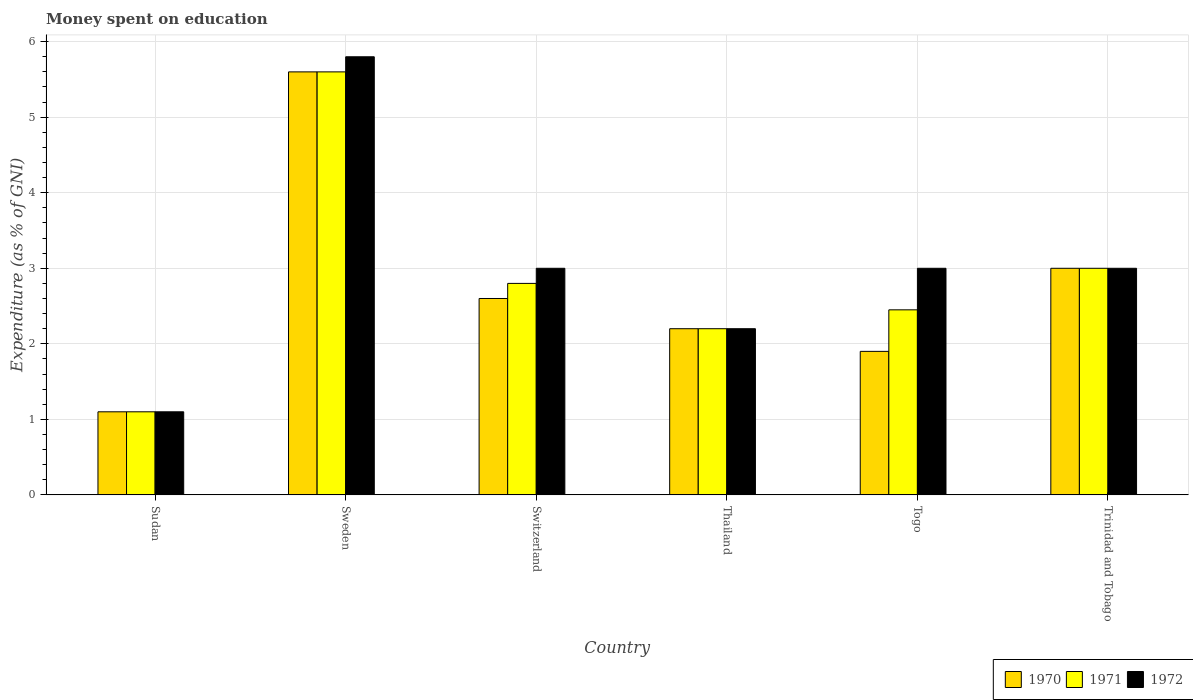How many groups of bars are there?
Your answer should be compact. 6. How many bars are there on the 1st tick from the right?
Provide a short and direct response. 3. What is the label of the 3rd group of bars from the left?
Ensure brevity in your answer.  Switzerland. In how many cases, is the number of bars for a given country not equal to the number of legend labels?
Give a very brief answer. 0. What is the amount of money spent on education in 1971 in Trinidad and Tobago?
Your answer should be compact. 3. Across all countries, what is the maximum amount of money spent on education in 1970?
Your answer should be very brief. 5.6. Across all countries, what is the minimum amount of money spent on education in 1972?
Your response must be concise. 1.1. In which country was the amount of money spent on education in 1970 minimum?
Offer a very short reply. Sudan. What is the total amount of money spent on education in 1970 in the graph?
Provide a succinct answer. 16.4. What is the difference between the amount of money spent on education in 1971 in Sudan and that in Thailand?
Offer a very short reply. -1.1. What is the difference between the amount of money spent on education in 1970 in Thailand and the amount of money spent on education in 1971 in Sweden?
Your answer should be very brief. -3.4. What is the average amount of money spent on education in 1972 per country?
Make the answer very short. 3.02. What is the difference between the amount of money spent on education of/in 1971 and amount of money spent on education of/in 1972 in Sweden?
Make the answer very short. -0.2. In how many countries, is the amount of money spent on education in 1970 greater than 5.6 %?
Your answer should be compact. 0. What is the ratio of the amount of money spent on education in 1970 in Thailand to that in Togo?
Give a very brief answer. 1.16. Is the amount of money spent on education in 1971 in Thailand less than that in Trinidad and Tobago?
Offer a very short reply. Yes. Is the difference between the amount of money spent on education in 1971 in Sweden and Trinidad and Tobago greater than the difference between the amount of money spent on education in 1972 in Sweden and Trinidad and Tobago?
Your answer should be compact. No. What is the difference between the highest and the second highest amount of money spent on education in 1970?
Give a very brief answer. -0.4. What is the difference between the highest and the lowest amount of money spent on education in 1972?
Give a very brief answer. 4.7. Is the sum of the amount of money spent on education in 1970 in Sudan and Switzerland greater than the maximum amount of money spent on education in 1971 across all countries?
Ensure brevity in your answer.  No. What does the 2nd bar from the left in Switzerland represents?
Offer a very short reply. 1971. What does the 1st bar from the right in Trinidad and Tobago represents?
Offer a very short reply. 1972. Are the values on the major ticks of Y-axis written in scientific E-notation?
Your answer should be very brief. No. Does the graph contain any zero values?
Make the answer very short. No. Does the graph contain grids?
Your answer should be very brief. Yes. How many legend labels are there?
Your answer should be compact. 3. How are the legend labels stacked?
Provide a short and direct response. Horizontal. What is the title of the graph?
Ensure brevity in your answer.  Money spent on education. What is the label or title of the X-axis?
Your response must be concise. Country. What is the label or title of the Y-axis?
Ensure brevity in your answer.  Expenditure (as % of GNI). What is the Expenditure (as % of GNI) of 1970 in Sudan?
Provide a short and direct response. 1.1. What is the Expenditure (as % of GNI) in 1971 in Sudan?
Ensure brevity in your answer.  1.1. What is the Expenditure (as % of GNI) in 1972 in Sweden?
Offer a terse response. 5.8. What is the Expenditure (as % of GNI) of 1972 in Switzerland?
Keep it short and to the point. 3. What is the Expenditure (as % of GNI) of 1970 in Togo?
Provide a succinct answer. 1.9. What is the Expenditure (as % of GNI) in 1971 in Togo?
Make the answer very short. 2.45. What is the Expenditure (as % of GNI) in 1972 in Togo?
Your response must be concise. 3. What is the Expenditure (as % of GNI) of 1970 in Trinidad and Tobago?
Your answer should be compact. 3. Across all countries, what is the maximum Expenditure (as % of GNI) of 1970?
Your answer should be very brief. 5.6. Across all countries, what is the maximum Expenditure (as % of GNI) of 1971?
Offer a terse response. 5.6. Across all countries, what is the maximum Expenditure (as % of GNI) in 1972?
Your answer should be very brief. 5.8. Across all countries, what is the minimum Expenditure (as % of GNI) in 1971?
Ensure brevity in your answer.  1.1. Across all countries, what is the minimum Expenditure (as % of GNI) of 1972?
Offer a terse response. 1.1. What is the total Expenditure (as % of GNI) in 1971 in the graph?
Make the answer very short. 17.15. What is the difference between the Expenditure (as % of GNI) of 1972 in Sudan and that in Sweden?
Provide a succinct answer. -4.7. What is the difference between the Expenditure (as % of GNI) in 1970 in Sudan and that in Switzerland?
Make the answer very short. -1.5. What is the difference between the Expenditure (as % of GNI) of 1971 in Sudan and that in Switzerland?
Your answer should be compact. -1.7. What is the difference between the Expenditure (as % of GNI) of 1972 in Sudan and that in Switzerland?
Your response must be concise. -1.9. What is the difference between the Expenditure (as % of GNI) in 1970 in Sudan and that in Togo?
Your answer should be compact. -0.8. What is the difference between the Expenditure (as % of GNI) of 1971 in Sudan and that in Togo?
Give a very brief answer. -1.35. What is the difference between the Expenditure (as % of GNI) in 1971 in Sudan and that in Trinidad and Tobago?
Provide a short and direct response. -1.9. What is the difference between the Expenditure (as % of GNI) of 1972 in Sudan and that in Trinidad and Tobago?
Your answer should be compact. -1.9. What is the difference between the Expenditure (as % of GNI) in 1971 in Sweden and that in Switzerland?
Make the answer very short. 2.8. What is the difference between the Expenditure (as % of GNI) of 1972 in Sweden and that in Switzerland?
Provide a short and direct response. 2.8. What is the difference between the Expenditure (as % of GNI) of 1971 in Sweden and that in Thailand?
Your response must be concise. 3.4. What is the difference between the Expenditure (as % of GNI) in 1970 in Sweden and that in Togo?
Offer a very short reply. 3.7. What is the difference between the Expenditure (as % of GNI) of 1971 in Sweden and that in Togo?
Offer a terse response. 3.15. What is the difference between the Expenditure (as % of GNI) in 1972 in Sweden and that in Togo?
Provide a short and direct response. 2.8. What is the difference between the Expenditure (as % of GNI) in 1972 in Switzerland and that in Thailand?
Keep it short and to the point. 0.8. What is the difference between the Expenditure (as % of GNI) in 1970 in Switzerland and that in Togo?
Your answer should be compact. 0.7. What is the difference between the Expenditure (as % of GNI) of 1971 in Switzerland and that in Togo?
Offer a very short reply. 0.35. What is the difference between the Expenditure (as % of GNI) of 1971 in Switzerland and that in Trinidad and Tobago?
Offer a terse response. -0.2. What is the difference between the Expenditure (as % of GNI) of 1970 in Thailand and that in Togo?
Your answer should be very brief. 0.3. What is the difference between the Expenditure (as % of GNI) in 1971 in Thailand and that in Togo?
Offer a very short reply. -0.25. What is the difference between the Expenditure (as % of GNI) of 1971 in Thailand and that in Trinidad and Tobago?
Your answer should be very brief. -0.8. What is the difference between the Expenditure (as % of GNI) in 1970 in Togo and that in Trinidad and Tobago?
Your response must be concise. -1.1. What is the difference between the Expenditure (as % of GNI) in 1971 in Togo and that in Trinidad and Tobago?
Your answer should be very brief. -0.55. What is the difference between the Expenditure (as % of GNI) of 1970 in Sudan and the Expenditure (as % of GNI) of 1971 in Sweden?
Your response must be concise. -4.5. What is the difference between the Expenditure (as % of GNI) of 1971 in Sudan and the Expenditure (as % of GNI) of 1972 in Sweden?
Your response must be concise. -4.7. What is the difference between the Expenditure (as % of GNI) of 1971 in Sudan and the Expenditure (as % of GNI) of 1972 in Switzerland?
Make the answer very short. -1.9. What is the difference between the Expenditure (as % of GNI) in 1971 in Sudan and the Expenditure (as % of GNI) in 1972 in Thailand?
Offer a very short reply. -1.1. What is the difference between the Expenditure (as % of GNI) in 1970 in Sudan and the Expenditure (as % of GNI) in 1971 in Togo?
Offer a terse response. -1.35. What is the difference between the Expenditure (as % of GNI) in 1970 in Sudan and the Expenditure (as % of GNI) in 1972 in Togo?
Provide a succinct answer. -1.9. What is the difference between the Expenditure (as % of GNI) in 1971 in Sudan and the Expenditure (as % of GNI) in 1972 in Togo?
Your answer should be compact. -1.9. What is the difference between the Expenditure (as % of GNI) in 1970 in Sweden and the Expenditure (as % of GNI) in 1971 in Thailand?
Provide a succinct answer. 3.4. What is the difference between the Expenditure (as % of GNI) in 1970 in Sweden and the Expenditure (as % of GNI) in 1971 in Togo?
Ensure brevity in your answer.  3.15. What is the difference between the Expenditure (as % of GNI) of 1971 in Sweden and the Expenditure (as % of GNI) of 1972 in Togo?
Your answer should be compact. 2.6. What is the difference between the Expenditure (as % of GNI) in 1970 in Sweden and the Expenditure (as % of GNI) in 1971 in Trinidad and Tobago?
Offer a very short reply. 2.6. What is the difference between the Expenditure (as % of GNI) in 1971 in Sweden and the Expenditure (as % of GNI) in 1972 in Trinidad and Tobago?
Provide a short and direct response. 2.6. What is the difference between the Expenditure (as % of GNI) of 1970 in Switzerland and the Expenditure (as % of GNI) of 1971 in Thailand?
Provide a short and direct response. 0.4. What is the difference between the Expenditure (as % of GNI) of 1970 in Switzerland and the Expenditure (as % of GNI) of 1972 in Thailand?
Offer a terse response. 0.4. What is the difference between the Expenditure (as % of GNI) of 1971 in Switzerland and the Expenditure (as % of GNI) of 1972 in Thailand?
Your response must be concise. 0.6. What is the difference between the Expenditure (as % of GNI) in 1970 in Switzerland and the Expenditure (as % of GNI) in 1971 in Togo?
Provide a succinct answer. 0.15. What is the difference between the Expenditure (as % of GNI) in 1970 in Switzerland and the Expenditure (as % of GNI) in 1972 in Togo?
Your response must be concise. -0.4. What is the difference between the Expenditure (as % of GNI) of 1971 in Thailand and the Expenditure (as % of GNI) of 1972 in Togo?
Offer a terse response. -0.8. What is the difference between the Expenditure (as % of GNI) in 1970 in Thailand and the Expenditure (as % of GNI) in 1971 in Trinidad and Tobago?
Make the answer very short. -0.8. What is the difference between the Expenditure (as % of GNI) in 1971 in Thailand and the Expenditure (as % of GNI) in 1972 in Trinidad and Tobago?
Make the answer very short. -0.8. What is the difference between the Expenditure (as % of GNI) of 1970 in Togo and the Expenditure (as % of GNI) of 1971 in Trinidad and Tobago?
Provide a short and direct response. -1.1. What is the difference between the Expenditure (as % of GNI) in 1970 in Togo and the Expenditure (as % of GNI) in 1972 in Trinidad and Tobago?
Your response must be concise. -1.1. What is the difference between the Expenditure (as % of GNI) of 1971 in Togo and the Expenditure (as % of GNI) of 1972 in Trinidad and Tobago?
Give a very brief answer. -0.55. What is the average Expenditure (as % of GNI) of 1970 per country?
Your answer should be very brief. 2.73. What is the average Expenditure (as % of GNI) of 1971 per country?
Offer a very short reply. 2.86. What is the average Expenditure (as % of GNI) of 1972 per country?
Make the answer very short. 3.02. What is the difference between the Expenditure (as % of GNI) of 1971 and Expenditure (as % of GNI) of 1972 in Sudan?
Give a very brief answer. 0. What is the difference between the Expenditure (as % of GNI) in 1970 and Expenditure (as % of GNI) in 1971 in Sweden?
Your response must be concise. 0. What is the difference between the Expenditure (as % of GNI) in 1970 and Expenditure (as % of GNI) in 1972 in Sweden?
Make the answer very short. -0.2. What is the difference between the Expenditure (as % of GNI) of 1970 and Expenditure (as % of GNI) of 1971 in Switzerland?
Offer a terse response. -0.2. What is the difference between the Expenditure (as % of GNI) of 1971 and Expenditure (as % of GNI) of 1972 in Switzerland?
Give a very brief answer. -0.2. What is the difference between the Expenditure (as % of GNI) of 1970 and Expenditure (as % of GNI) of 1972 in Thailand?
Ensure brevity in your answer.  0. What is the difference between the Expenditure (as % of GNI) of 1971 and Expenditure (as % of GNI) of 1972 in Thailand?
Your answer should be compact. 0. What is the difference between the Expenditure (as % of GNI) of 1970 and Expenditure (as % of GNI) of 1971 in Togo?
Provide a succinct answer. -0.55. What is the difference between the Expenditure (as % of GNI) of 1970 and Expenditure (as % of GNI) of 1972 in Togo?
Your answer should be compact. -1.1. What is the difference between the Expenditure (as % of GNI) of 1971 and Expenditure (as % of GNI) of 1972 in Togo?
Your answer should be compact. -0.55. What is the difference between the Expenditure (as % of GNI) in 1970 and Expenditure (as % of GNI) in 1972 in Trinidad and Tobago?
Ensure brevity in your answer.  0. What is the difference between the Expenditure (as % of GNI) of 1971 and Expenditure (as % of GNI) of 1972 in Trinidad and Tobago?
Your answer should be very brief. 0. What is the ratio of the Expenditure (as % of GNI) in 1970 in Sudan to that in Sweden?
Provide a succinct answer. 0.2. What is the ratio of the Expenditure (as % of GNI) of 1971 in Sudan to that in Sweden?
Provide a short and direct response. 0.2. What is the ratio of the Expenditure (as % of GNI) in 1972 in Sudan to that in Sweden?
Provide a succinct answer. 0.19. What is the ratio of the Expenditure (as % of GNI) in 1970 in Sudan to that in Switzerland?
Your answer should be compact. 0.42. What is the ratio of the Expenditure (as % of GNI) in 1971 in Sudan to that in Switzerland?
Your response must be concise. 0.39. What is the ratio of the Expenditure (as % of GNI) in 1972 in Sudan to that in Switzerland?
Provide a succinct answer. 0.37. What is the ratio of the Expenditure (as % of GNI) in 1970 in Sudan to that in Togo?
Your answer should be compact. 0.58. What is the ratio of the Expenditure (as % of GNI) in 1971 in Sudan to that in Togo?
Ensure brevity in your answer.  0.45. What is the ratio of the Expenditure (as % of GNI) of 1972 in Sudan to that in Togo?
Your answer should be compact. 0.37. What is the ratio of the Expenditure (as % of GNI) in 1970 in Sudan to that in Trinidad and Tobago?
Keep it short and to the point. 0.37. What is the ratio of the Expenditure (as % of GNI) in 1971 in Sudan to that in Trinidad and Tobago?
Give a very brief answer. 0.37. What is the ratio of the Expenditure (as % of GNI) of 1972 in Sudan to that in Trinidad and Tobago?
Offer a very short reply. 0.37. What is the ratio of the Expenditure (as % of GNI) in 1970 in Sweden to that in Switzerland?
Give a very brief answer. 2.15. What is the ratio of the Expenditure (as % of GNI) in 1971 in Sweden to that in Switzerland?
Keep it short and to the point. 2. What is the ratio of the Expenditure (as % of GNI) of 1972 in Sweden to that in Switzerland?
Keep it short and to the point. 1.93. What is the ratio of the Expenditure (as % of GNI) of 1970 in Sweden to that in Thailand?
Provide a succinct answer. 2.55. What is the ratio of the Expenditure (as % of GNI) of 1971 in Sweden to that in Thailand?
Give a very brief answer. 2.55. What is the ratio of the Expenditure (as % of GNI) of 1972 in Sweden to that in Thailand?
Keep it short and to the point. 2.64. What is the ratio of the Expenditure (as % of GNI) in 1970 in Sweden to that in Togo?
Your response must be concise. 2.95. What is the ratio of the Expenditure (as % of GNI) in 1971 in Sweden to that in Togo?
Provide a short and direct response. 2.29. What is the ratio of the Expenditure (as % of GNI) in 1972 in Sweden to that in Togo?
Provide a short and direct response. 1.93. What is the ratio of the Expenditure (as % of GNI) in 1970 in Sweden to that in Trinidad and Tobago?
Make the answer very short. 1.87. What is the ratio of the Expenditure (as % of GNI) of 1971 in Sweden to that in Trinidad and Tobago?
Make the answer very short. 1.87. What is the ratio of the Expenditure (as % of GNI) in 1972 in Sweden to that in Trinidad and Tobago?
Offer a very short reply. 1.93. What is the ratio of the Expenditure (as % of GNI) of 1970 in Switzerland to that in Thailand?
Give a very brief answer. 1.18. What is the ratio of the Expenditure (as % of GNI) of 1971 in Switzerland to that in Thailand?
Your response must be concise. 1.27. What is the ratio of the Expenditure (as % of GNI) of 1972 in Switzerland to that in Thailand?
Offer a very short reply. 1.36. What is the ratio of the Expenditure (as % of GNI) in 1970 in Switzerland to that in Togo?
Your response must be concise. 1.37. What is the ratio of the Expenditure (as % of GNI) of 1971 in Switzerland to that in Togo?
Provide a succinct answer. 1.14. What is the ratio of the Expenditure (as % of GNI) in 1970 in Switzerland to that in Trinidad and Tobago?
Your answer should be very brief. 0.87. What is the ratio of the Expenditure (as % of GNI) in 1970 in Thailand to that in Togo?
Your response must be concise. 1.16. What is the ratio of the Expenditure (as % of GNI) of 1971 in Thailand to that in Togo?
Offer a terse response. 0.9. What is the ratio of the Expenditure (as % of GNI) of 1972 in Thailand to that in Togo?
Offer a very short reply. 0.73. What is the ratio of the Expenditure (as % of GNI) in 1970 in Thailand to that in Trinidad and Tobago?
Your answer should be compact. 0.73. What is the ratio of the Expenditure (as % of GNI) in 1971 in Thailand to that in Trinidad and Tobago?
Keep it short and to the point. 0.73. What is the ratio of the Expenditure (as % of GNI) in 1972 in Thailand to that in Trinidad and Tobago?
Offer a very short reply. 0.73. What is the ratio of the Expenditure (as % of GNI) of 1970 in Togo to that in Trinidad and Tobago?
Give a very brief answer. 0.63. What is the ratio of the Expenditure (as % of GNI) of 1971 in Togo to that in Trinidad and Tobago?
Provide a short and direct response. 0.82. What is the difference between the highest and the second highest Expenditure (as % of GNI) of 1972?
Offer a terse response. 2.8. What is the difference between the highest and the lowest Expenditure (as % of GNI) of 1971?
Offer a terse response. 4.5. What is the difference between the highest and the lowest Expenditure (as % of GNI) in 1972?
Keep it short and to the point. 4.7. 